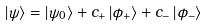<formula> <loc_0><loc_0><loc_500><loc_500>\left | \psi \right \rangle = \left | \psi _ { 0 } \right \rangle + c _ { + } \left | \phi _ { + } \right \rangle + c _ { - } \left | \phi _ { - } \right \rangle</formula> 